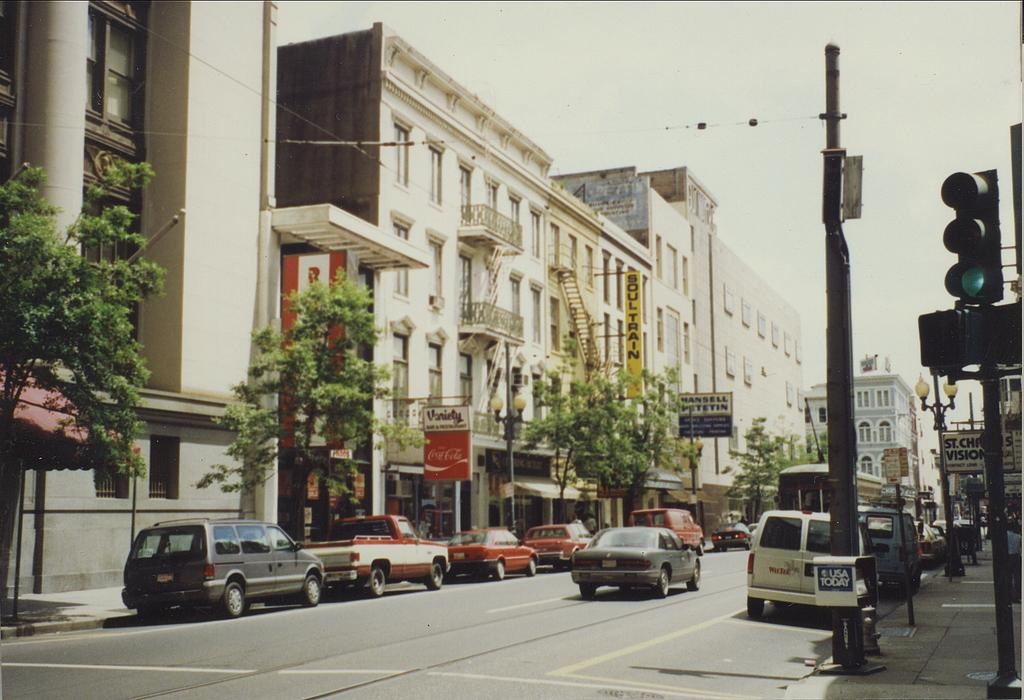What can be seen on the road in the image? There are vehicles on the road in the image. What type of structures are visible with windows? There are buildings with windows in the image. What type of vegetation is present in the image? There are trees in the image. What device is used to control traffic in the image? There is a signal in the image. What part of the natural environment is visible in the image? The sky is visible in the image. Can you tell me how many needles are sticking out of the trees in the image? There are no needles present in the image; it features trees with leaves or branches. What type of shock can be seen affecting the buildings in the image? There is no shock present in the image; the buildings appear to be standing normally. 